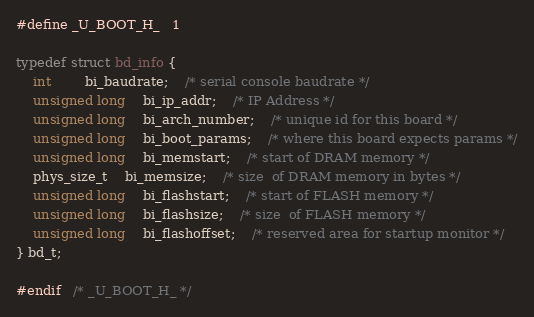Convert code to text. <code><loc_0><loc_0><loc_500><loc_500><_C_>#define _U_BOOT_H_	1

typedef struct bd_info {
	int		bi_baudrate;	/* serial console baudrate */
	unsigned long	bi_ip_addr;	/* IP Address */
	unsigned long	bi_arch_number;	/* unique id for this board */
	unsigned long	bi_boot_params;	/* where this board expects params */
	unsigned long	bi_memstart;	/* start of DRAM memory */
	phys_size_t	bi_memsize;	/* size	 of DRAM memory in bytes */
	unsigned long	bi_flashstart;	/* start of FLASH memory */
	unsigned long	bi_flashsize;	/* size  of FLASH memory */
	unsigned long	bi_flashoffset;	/* reserved area for startup monitor */
} bd_t;

#endif	/* _U_BOOT_H_ */
</code> 